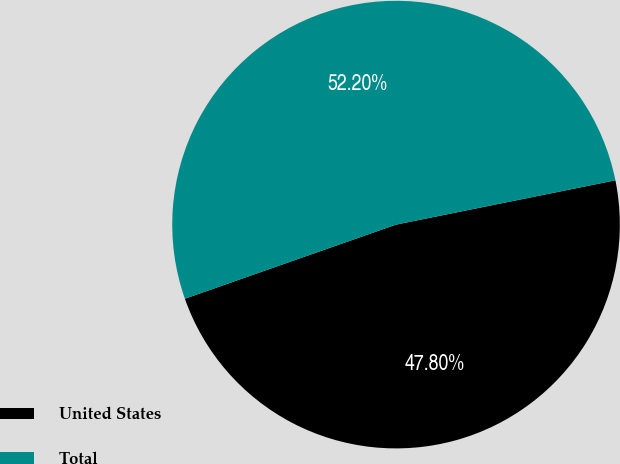Convert chart. <chart><loc_0><loc_0><loc_500><loc_500><pie_chart><fcel>United States<fcel>Total<nl><fcel>47.8%<fcel>52.2%<nl></chart> 